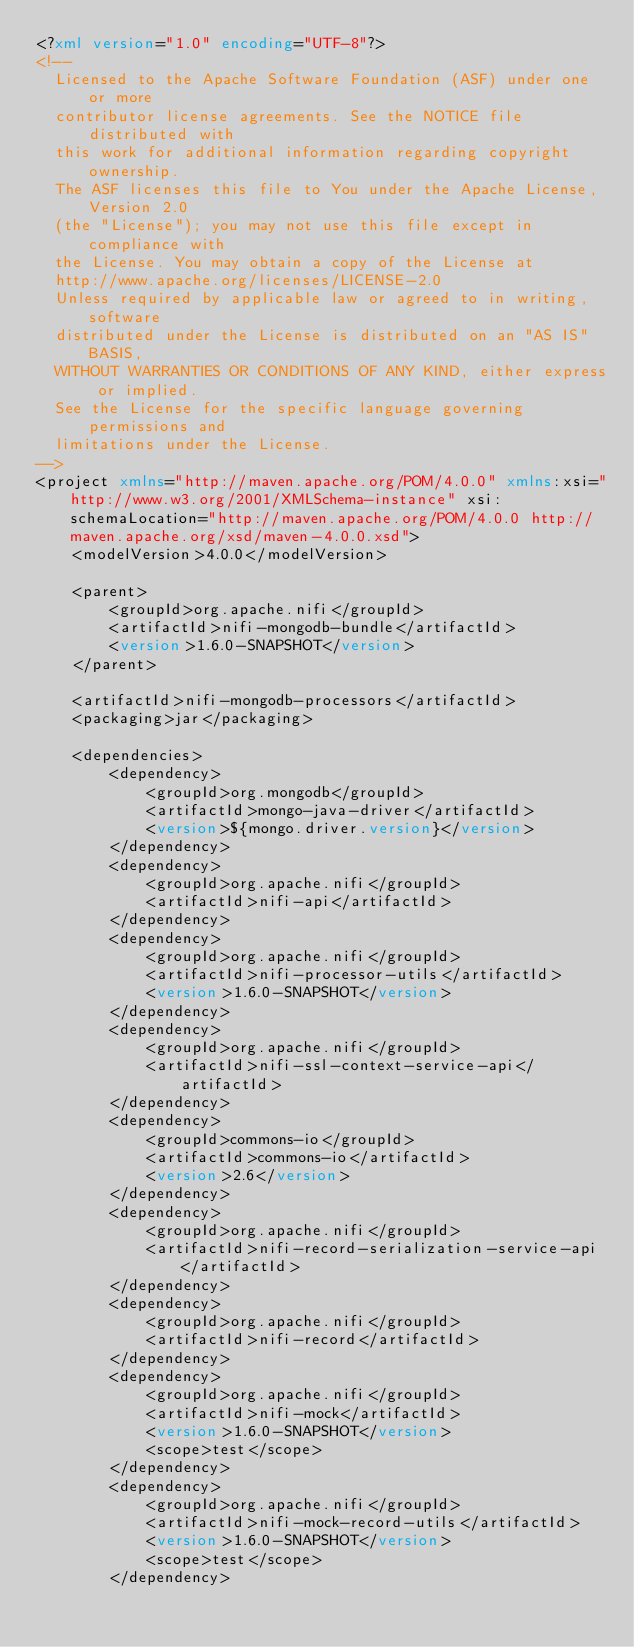Convert code to text. <code><loc_0><loc_0><loc_500><loc_500><_XML_><?xml version="1.0" encoding="UTF-8"?>
<!--
  Licensed to the Apache Software Foundation (ASF) under one or more
  contributor license agreements. See the NOTICE file distributed with
  this work for additional information regarding copyright ownership.
  The ASF licenses this file to You under the Apache License, Version 2.0
  (the "License"); you may not use this file except in compliance with
  the License. You may obtain a copy of the License at
  http://www.apache.org/licenses/LICENSE-2.0
  Unless required by applicable law or agreed to in writing, software
  distributed under the License is distributed on an "AS IS" BASIS,
  WITHOUT WARRANTIES OR CONDITIONS OF ANY KIND, either express or implied.
  See the License for the specific language governing permissions and
  limitations under the License.
-->
<project xmlns="http://maven.apache.org/POM/4.0.0" xmlns:xsi="http://www.w3.org/2001/XMLSchema-instance" xsi:schemaLocation="http://maven.apache.org/POM/4.0.0 http://maven.apache.org/xsd/maven-4.0.0.xsd">
    <modelVersion>4.0.0</modelVersion>

    <parent>
        <groupId>org.apache.nifi</groupId>
        <artifactId>nifi-mongodb-bundle</artifactId>
        <version>1.6.0-SNAPSHOT</version>
    </parent>

    <artifactId>nifi-mongodb-processors</artifactId>
    <packaging>jar</packaging>

    <dependencies>
        <dependency>
            <groupId>org.mongodb</groupId>
            <artifactId>mongo-java-driver</artifactId>
            <version>${mongo.driver.version}</version>
        </dependency>
        <dependency>
            <groupId>org.apache.nifi</groupId>
            <artifactId>nifi-api</artifactId>
        </dependency>
        <dependency>
            <groupId>org.apache.nifi</groupId>
            <artifactId>nifi-processor-utils</artifactId>
            <version>1.6.0-SNAPSHOT</version>
        </dependency>
        <dependency>
            <groupId>org.apache.nifi</groupId>
            <artifactId>nifi-ssl-context-service-api</artifactId>
        </dependency>
        <dependency>
            <groupId>commons-io</groupId>
            <artifactId>commons-io</artifactId>
            <version>2.6</version>
        </dependency>
        <dependency>
            <groupId>org.apache.nifi</groupId>
            <artifactId>nifi-record-serialization-service-api</artifactId>
        </dependency>
        <dependency>
            <groupId>org.apache.nifi</groupId>
            <artifactId>nifi-record</artifactId>
        </dependency>
        <dependency>
            <groupId>org.apache.nifi</groupId>
            <artifactId>nifi-mock</artifactId>
            <version>1.6.0-SNAPSHOT</version>
            <scope>test</scope>
        </dependency>
        <dependency>
            <groupId>org.apache.nifi</groupId>
            <artifactId>nifi-mock-record-utils</artifactId>
            <version>1.6.0-SNAPSHOT</version>
            <scope>test</scope>
        </dependency></code> 